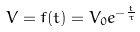Convert formula to latex. <formula><loc_0><loc_0><loc_500><loc_500>V = f ( t ) = V _ { 0 } e ^ { - \frac { t } { \tau } }</formula> 